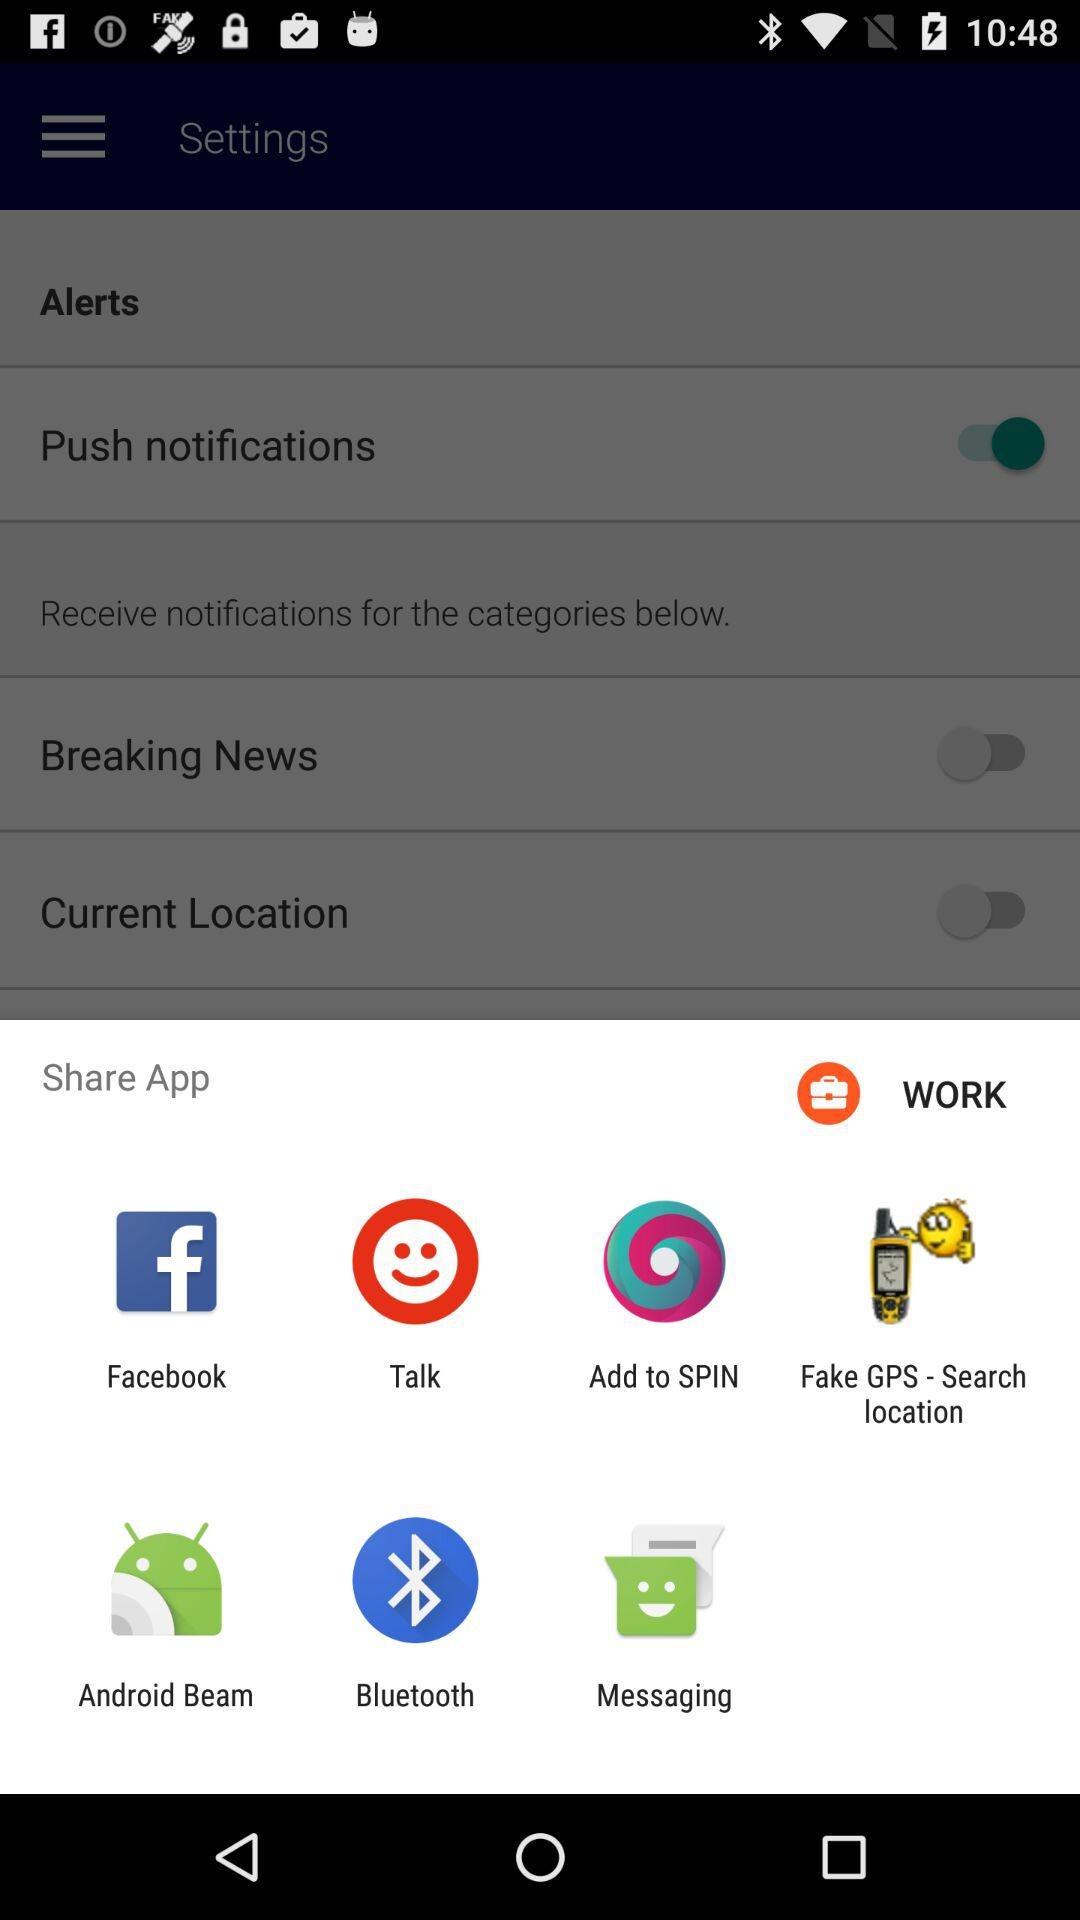What is the status of the current location? The status is off. 